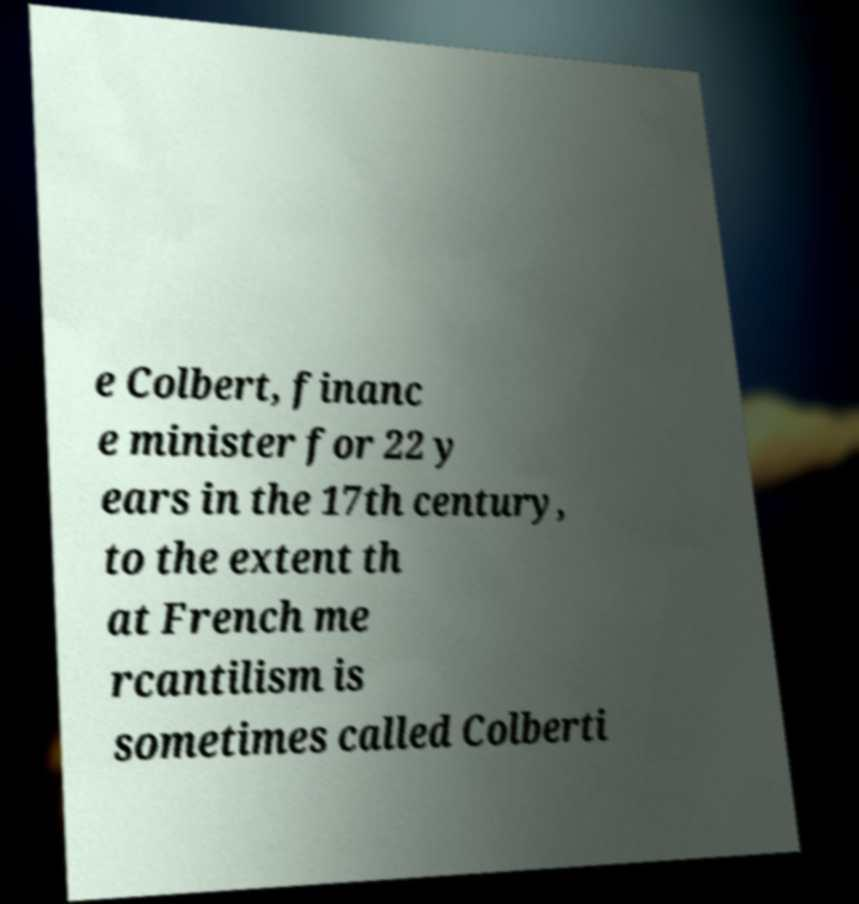What messages or text are displayed in this image? I need them in a readable, typed format. e Colbert, financ e minister for 22 y ears in the 17th century, to the extent th at French me rcantilism is sometimes called Colberti 